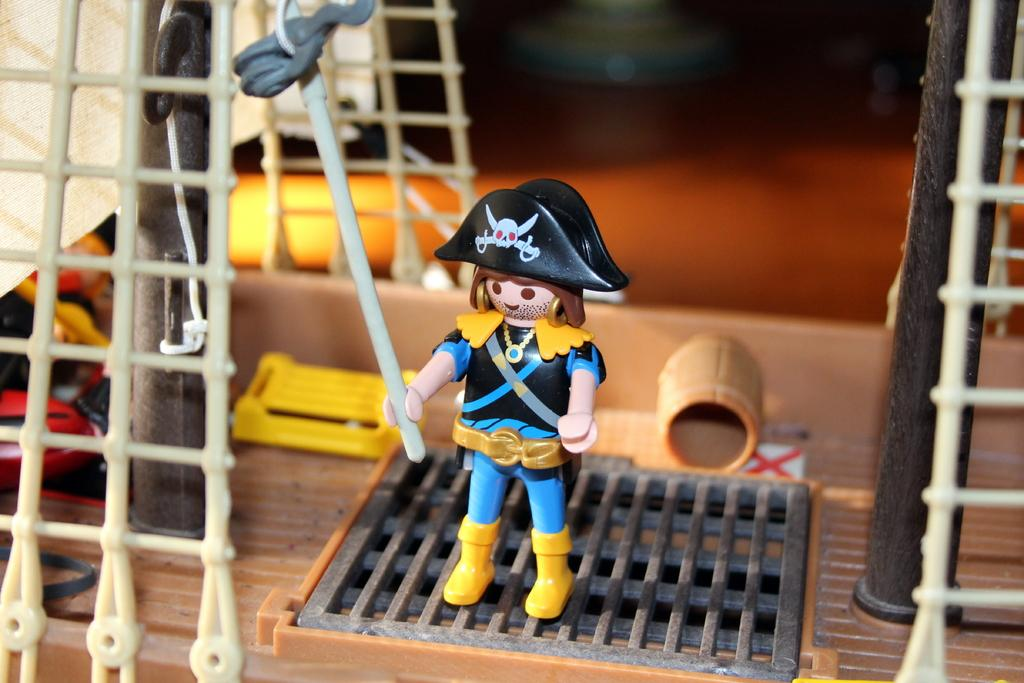What objects can be seen in the image? There are toys in the image. Can you describe the background of the image? The background of the image is blurred. How many legs can be seen on the toys in the image? There is no information about the number of legs on the toys in the image, as the focus is on the presence of toys and the blurred background. 